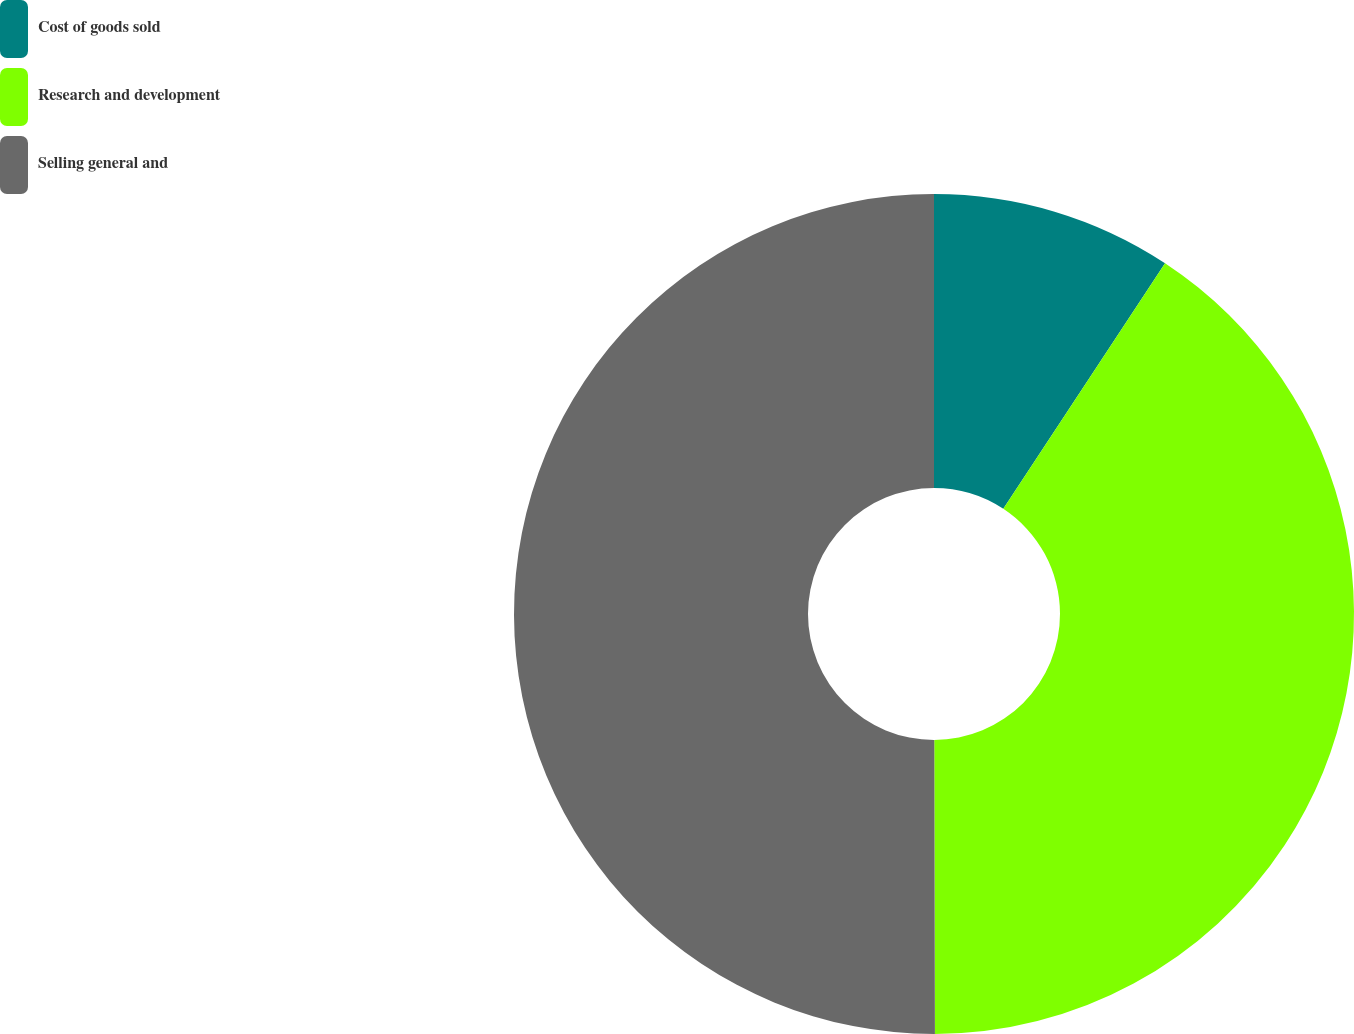<chart> <loc_0><loc_0><loc_500><loc_500><pie_chart><fcel>Cost of goods sold<fcel>Research and development<fcel>Selling general and<nl><fcel>9.27%<fcel>40.69%<fcel>50.03%<nl></chart> 